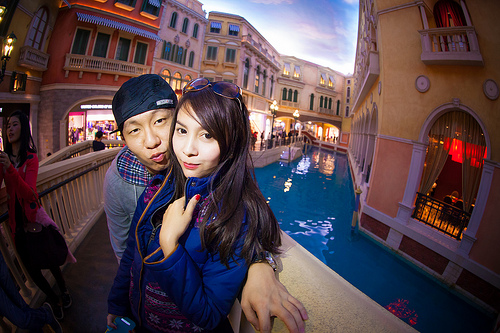<image>
Is there a girl on the boy? No. The girl is not positioned on the boy. They may be near each other, but the girl is not supported by or resting on top of the boy. Is there a couple on the water? No. The couple is not positioned on the water. They may be near each other, but the couple is not supported by or resting on top of the water. Is the woman in front of the man? Yes. The woman is positioned in front of the man, appearing closer to the camera viewpoint. 